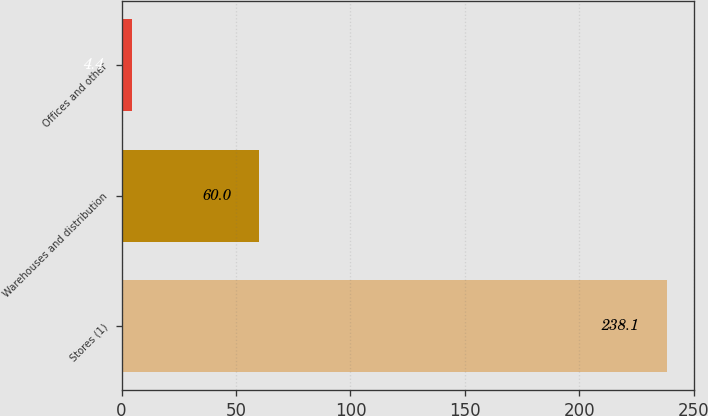Convert chart to OTSL. <chart><loc_0><loc_0><loc_500><loc_500><bar_chart><fcel>Stores (1)<fcel>Warehouses and distribution<fcel>Offices and other<nl><fcel>238.1<fcel>60<fcel>4.4<nl></chart> 